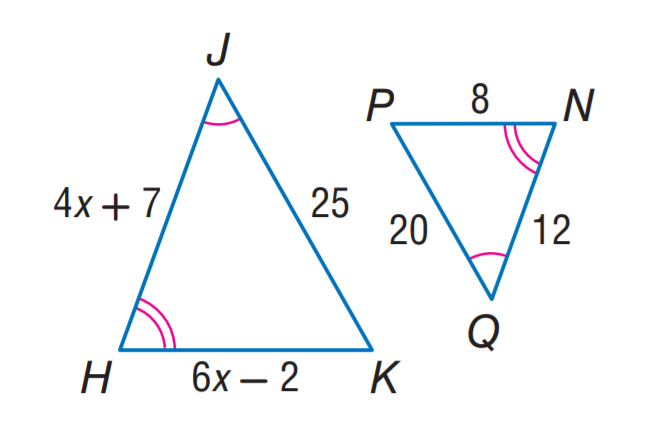Answer the mathemtical geometry problem and directly provide the correct option letter.
Question: Find H J.
Choices: A: 10 B: 12 C: 15 D: 25 C 